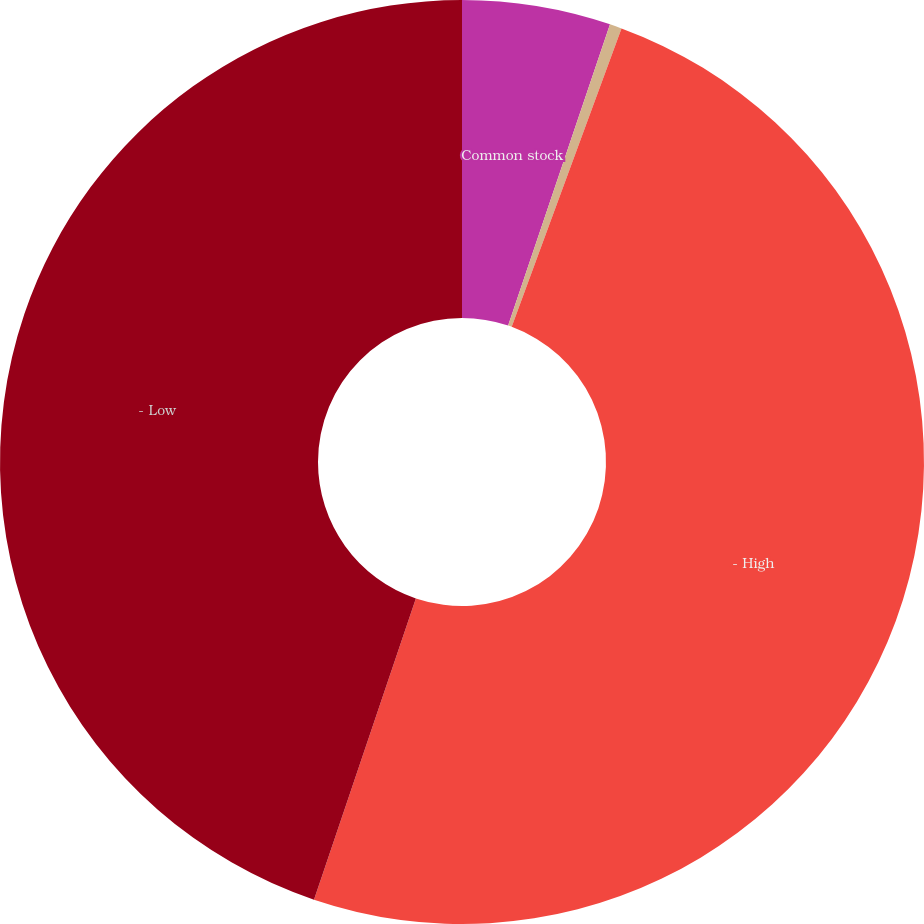Convert chart. <chart><loc_0><loc_0><loc_500><loc_500><pie_chart><fcel>Common stock<fcel>25 par preferred stock<fcel>- High<fcel>- Low<nl><fcel>5.19%<fcel>0.42%<fcel>49.58%<fcel>44.81%<nl></chart> 